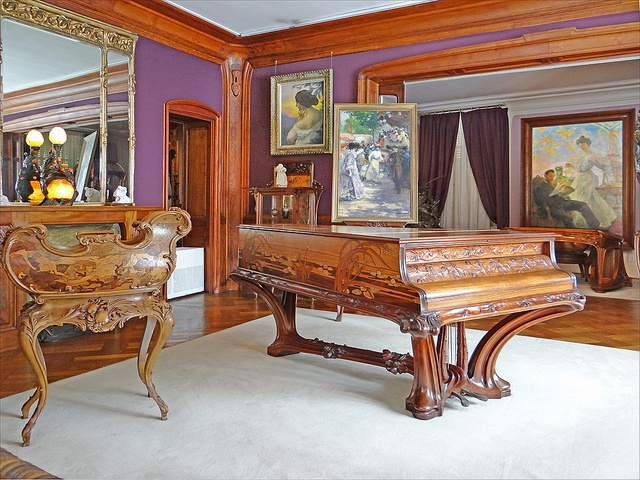Describe the objects in this image and their specific colors. I can see a chair in darkgray, brown, tan, gray, and maroon tones in this image. 